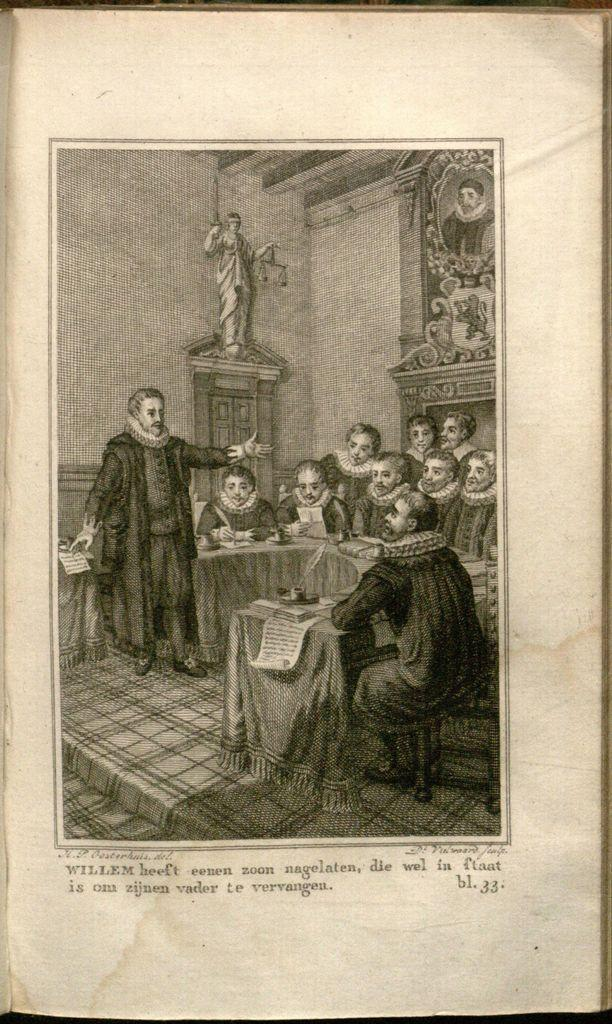What is the main subject of the paper in the image? The paper contains images of people and a statue. What else can be found on the paper besides the images? There is text on the paper. What sense is being stimulated by the flesh in the image? There is no flesh present in the image, so it is not possible to determine which sense might be stimulated. 